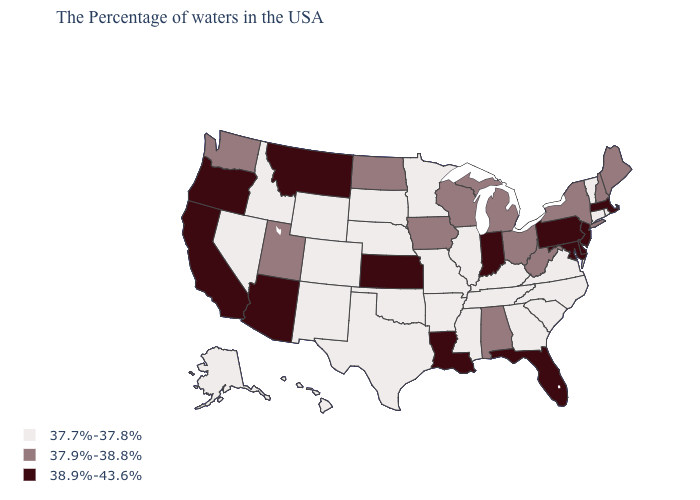Which states have the lowest value in the West?
Short answer required. Wyoming, Colorado, New Mexico, Idaho, Nevada, Alaska, Hawaii. Which states have the highest value in the USA?
Give a very brief answer. Massachusetts, New Jersey, Delaware, Maryland, Pennsylvania, Florida, Indiana, Louisiana, Kansas, Montana, Arizona, California, Oregon. What is the lowest value in the USA?
Give a very brief answer. 37.7%-37.8%. Among the states that border Nebraska , which have the highest value?
Give a very brief answer. Kansas. Does North Dakota have the same value as New York?
Short answer required. Yes. Name the states that have a value in the range 38.9%-43.6%?
Concise answer only. Massachusetts, New Jersey, Delaware, Maryland, Pennsylvania, Florida, Indiana, Louisiana, Kansas, Montana, Arizona, California, Oregon. Name the states that have a value in the range 37.9%-38.8%?
Be succinct. Maine, New Hampshire, New York, West Virginia, Ohio, Michigan, Alabama, Wisconsin, Iowa, North Dakota, Utah, Washington. Is the legend a continuous bar?
Keep it brief. No. Which states have the lowest value in the USA?
Write a very short answer. Rhode Island, Vermont, Connecticut, Virginia, North Carolina, South Carolina, Georgia, Kentucky, Tennessee, Illinois, Mississippi, Missouri, Arkansas, Minnesota, Nebraska, Oklahoma, Texas, South Dakota, Wyoming, Colorado, New Mexico, Idaho, Nevada, Alaska, Hawaii. Name the states that have a value in the range 37.7%-37.8%?
Write a very short answer. Rhode Island, Vermont, Connecticut, Virginia, North Carolina, South Carolina, Georgia, Kentucky, Tennessee, Illinois, Mississippi, Missouri, Arkansas, Minnesota, Nebraska, Oklahoma, Texas, South Dakota, Wyoming, Colorado, New Mexico, Idaho, Nevada, Alaska, Hawaii. Name the states that have a value in the range 37.9%-38.8%?
Be succinct. Maine, New Hampshire, New York, West Virginia, Ohio, Michigan, Alabama, Wisconsin, Iowa, North Dakota, Utah, Washington. What is the value of New Hampshire?
Write a very short answer. 37.9%-38.8%. What is the value of Georgia?
Answer briefly. 37.7%-37.8%. What is the value of Delaware?
Concise answer only. 38.9%-43.6%. 